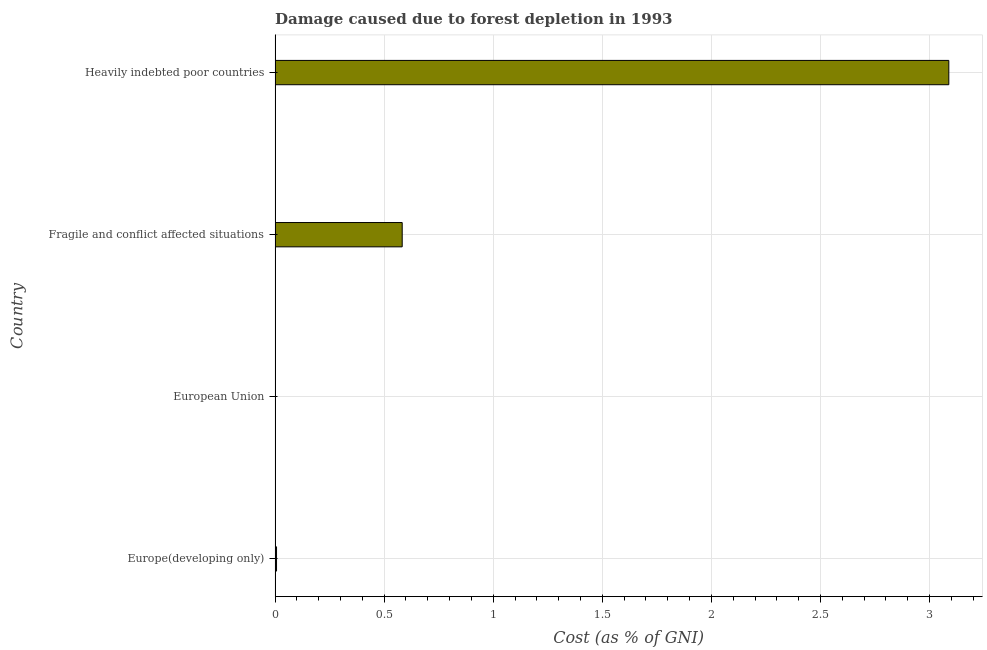Does the graph contain any zero values?
Provide a succinct answer. No. What is the title of the graph?
Give a very brief answer. Damage caused due to forest depletion in 1993. What is the label or title of the X-axis?
Give a very brief answer. Cost (as % of GNI). What is the label or title of the Y-axis?
Your answer should be very brief. Country. What is the damage caused due to forest depletion in Heavily indebted poor countries?
Give a very brief answer. 3.09. Across all countries, what is the maximum damage caused due to forest depletion?
Keep it short and to the point. 3.09. Across all countries, what is the minimum damage caused due to forest depletion?
Keep it short and to the point. 0. In which country was the damage caused due to forest depletion maximum?
Provide a short and direct response. Heavily indebted poor countries. What is the sum of the damage caused due to forest depletion?
Provide a succinct answer. 3.68. What is the difference between the damage caused due to forest depletion in Fragile and conflict affected situations and Heavily indebted poor countries?
Provide a short and direct response. -2.5. What is the median damage caused due to forest depletion?
Offer a very short reply. 0.29. What is the ratio of the damage caused due to forest depletion in Europe(developing only) to that in Fragile and conflict affected situations?
Your response must be concise. 0.01. Is the difference between the damage caused due to forest depletion in Fragile and conflict affected situations and Heavily indebted poor countries greater than the difference between any two countries?
Your answer should be very brief. No. What is the difference between the highest and the second highest damage caused due to forest depletion?
Keep it short and to the point. 2.5. Is the sum of the damage caused due to forest depletion in Europe(developing only) and Heavily indebted poor countries greater than the maximum damage caused due to forest depletion across all countries?
Offer a terse response. Yes. What is the difference between the highest and the lowest damage caused due to forest depletion?
Your answer should be compact. 3.09. In how many countries, is the damage caused due to forest depletion greater than the average damage caused due to forest depletion taken over all countries?
Your response must be concise. 1. How many bars are there?
Your answer should be compact. 4. What is the difference between two consecutive major ticks on the X-axis?
Offer a very short reply. 0.5. Are the values on the major ticks of X-axis written in scientific E-notation?
Provide a succinct answer. No. What is the Cost (as % of GNI) of Europe(developing only)?
Your answer should be compact. 0.01. What is the Cost (as % of GNI) of European Union?
Keep it short and to the point. 0. What is the Cost (as % of GNI) of Fragile and conflict affected situations?
Offer a very short reply. 0.58. What is the Cost (as % of GNI) of Heavily indebted poor countries?
Offer a very short reply. 3.09. What is the difference between the Cost (as % of GNI) in Europe(developing only) and European Union?
Ensure brevity in your answer.  0. What is the difference between the Cost (as % of GNI) in Europe(developing only) and Fragile and conflict affected situations?
Provide a short and direct response. -0.58. What is the difference between the Cost (as % of GNI) in Europe(developing only) and Heavily indebted poor countries?
Give a very brief answer. -3.08. What is the difference between the Cost (as % of GNI) in European Union and Fragile and conflict affected situations?
Make the answer very short. -0.58. What is the difference between the Cost (as % of GNI) in European Union and Heavily indebted poor countries?
Keep it short and to the point. -3.09. What is the difference between the Cost (as % of GNI) in Fragile and conflict affected situations and Heavily indebted poor countries?
Make the answer very short. -2.51. What is the ratio of the Cost (as % of GNI) in Europe(developing only) to that in European Union?
Keep it short and to the point. 3.54. What is the ratio of the Cost (as % of GNI) in Europe(developing only) to that in Fragile and conflict affected situations?
Make the answer very short. 0.01. What is the ratio of the Cost (as % of GNI) in Europe(developing only) to that in Heavily indebted poor countries?
Make the answer very short. 0. What is the ratio of the Cost (as % of GNI) in European Union to that in Fragile and conflict affected situations?
Offer a very short reply. 0. What is the ratio of the Cost (as % of GNI) in Fragile and conflict affected situations to that in Heavily indebted poor countries?
Your response must be concise. 0.19. 